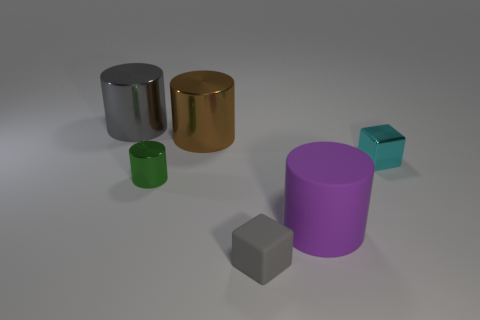Add 2 blocks. How many objects exist? 8 Subtract all cylinders. How many objects are left? 2 Subtract all gray things. Subtract all cyan metallic objects. How many objects are left? 3 Add 2 gray blocks. How many gray blocks are left? 3 Add 1 yellow metal cylinders. How many yellow metal cylinders exist? 1 Subtract 1 cyan blocks. How many objects are left? 5 